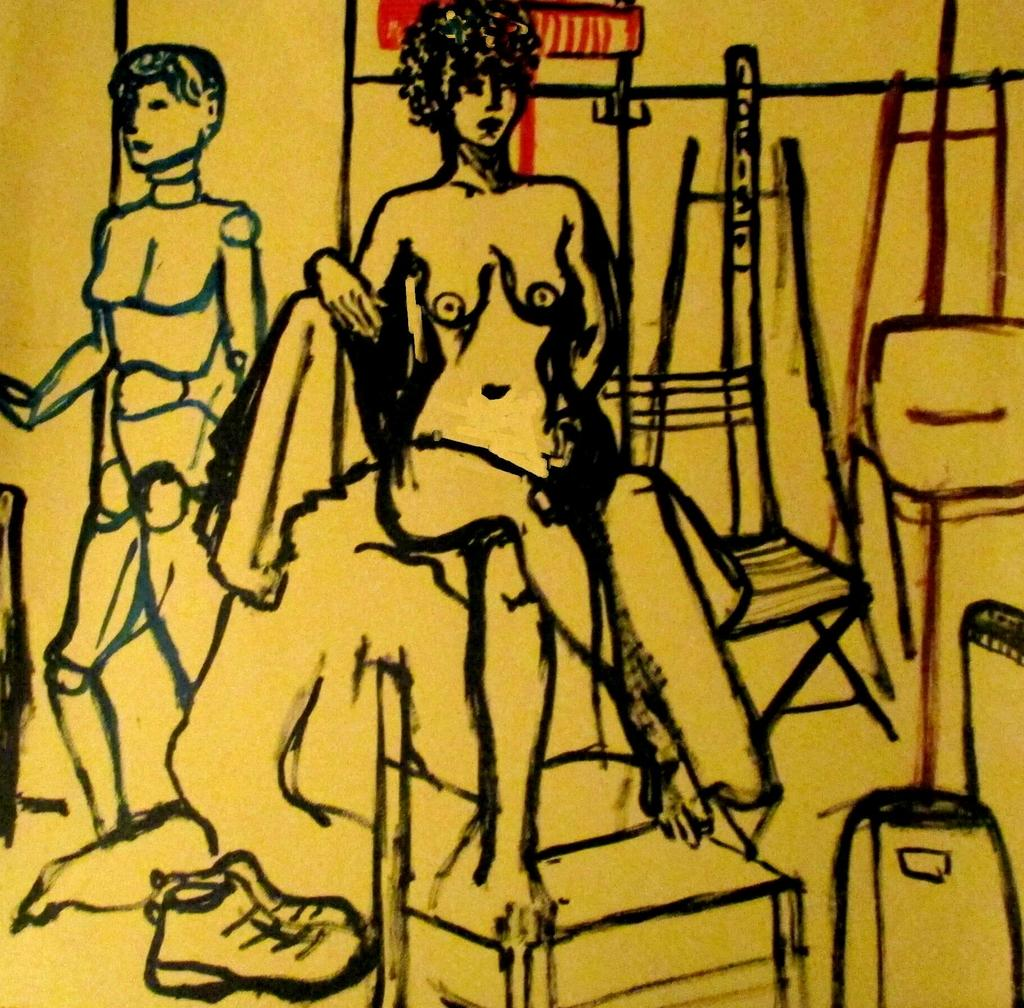What type of artwork is visible in the image? There are paintings in the image. What color is the background of the paintings? The background of the paintings is yellow. Can you see any veins in the paintings in the image? There is no mention of veins in the provided facts, and therefore it cannot be determined if they are present in the paintings. 